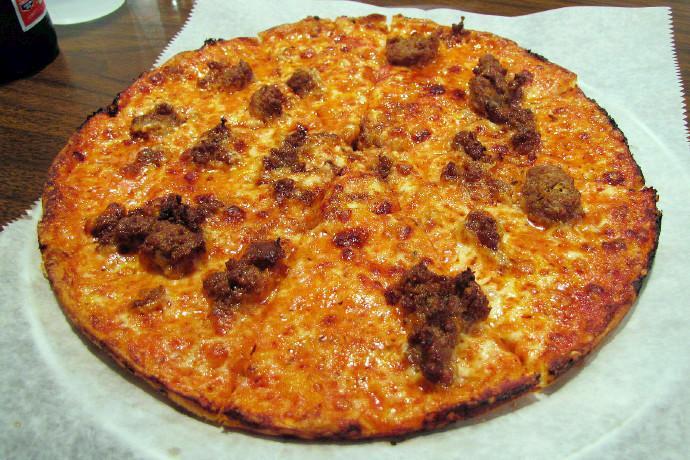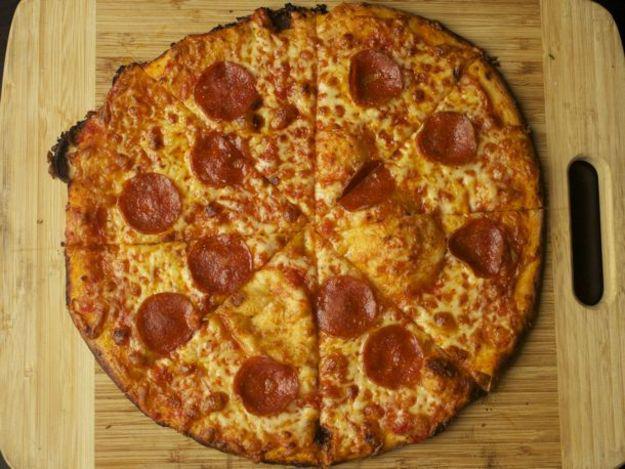The first image is the image on the left, the second image is the image on the right. For the images shown, is this caption "There is pepperoni on one pizza but not the other." true? Answer yes or no. Yes. 